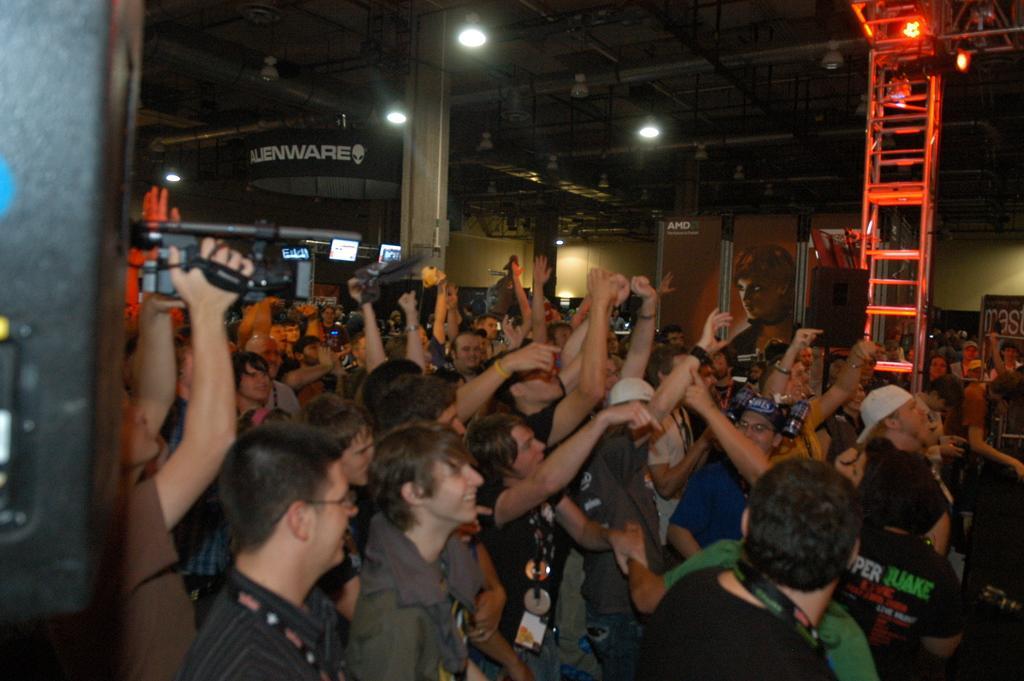Describe this image in one or two sentences. In this image I can see crowd visible in the foreground and I can see a person holding a gun on the left side in the middle there are some lights attached to the roof, there might be the ladder visible on the right side, and there is the wall visible in the middle. 